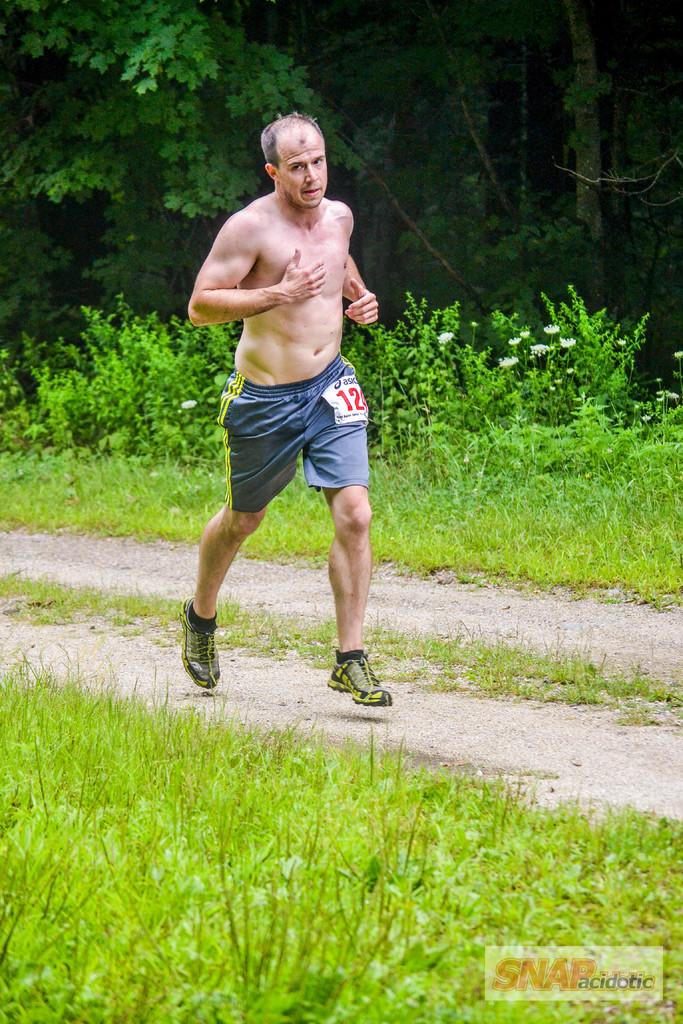What's this runner tag number?
Provide a short and direct response. 12. What´s the name of the company  on the bottom of the picture?
Your response must be concise. Snap acidotic. 